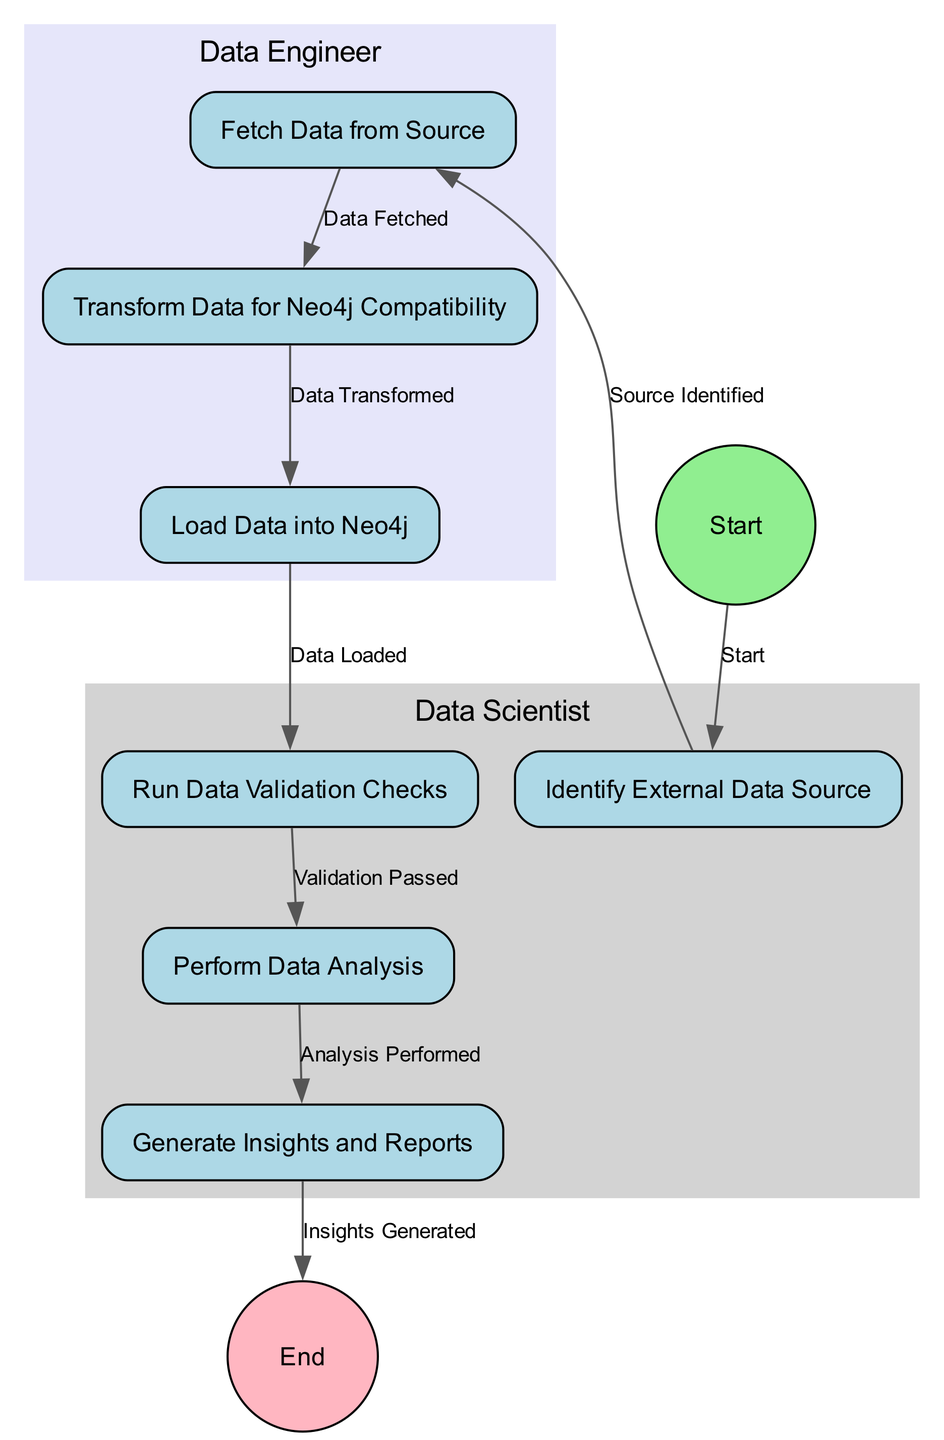What is the first activity in the diagram? The first activity is represented by the node with ID "1", which is labeled "Start". This is the entry point of the activity flow in the diagram.
Answer: Start How many activities are performed by the Data Scientist? The activities performed by the Data Scientist are identified by their assignments to swimlane "A". These activities are "Identify External Data Source", "Run Data Validation Checks", "Perform Data Analysis", and "Generate Insights and Reports". There are four such activities.
Answer: 4 Which node comes after "Transform Data for Neo4j Compatibility"? Following the node labeled "Transform Data for Neo4j Compatibility", which has the ID "4", the next node in the flow, as indicated by the transition, is "Load Data into Neo4j".
Answer: Load Data into Neo4j What is the result of passing the validation checks? The transition from "Run Data Validation Checks" to "Perform Data Analysis" indicates that upon passing the validation checks, the process moves forward to performing data analysis.
Answer: Perform Data Analysis Which two roles are depicted in the diagram? The two swimlanes identify the roles involved in the activities: "Data Scientist" and "Data Engineer". Each role is responsible for specific activities within the process.
Answer: Data Scientist, Data Engineer What is the last activity before the end of the process? The node just before the terminating point "End", represented by ID "9", is "Generate Insights and Reports", which signifies the final task in the activity flow.
Answer: Generate Insights and Reports How many transitions are present in the diagram? The transitions are the arrows that depict the movement from one activity to another. Counting the transitions listed in the diagram, there are a total of eight transitions connecting the activities.
Answer: 8 Which swimlane contains the activity "Fetch Data from Source"? The activity "Fetch Data from Source" is assigned to the swimlane identified by "B", which corresponds to the role of the Data Engineer, as seen in the activity assignments.
Answer: Data Engineer 